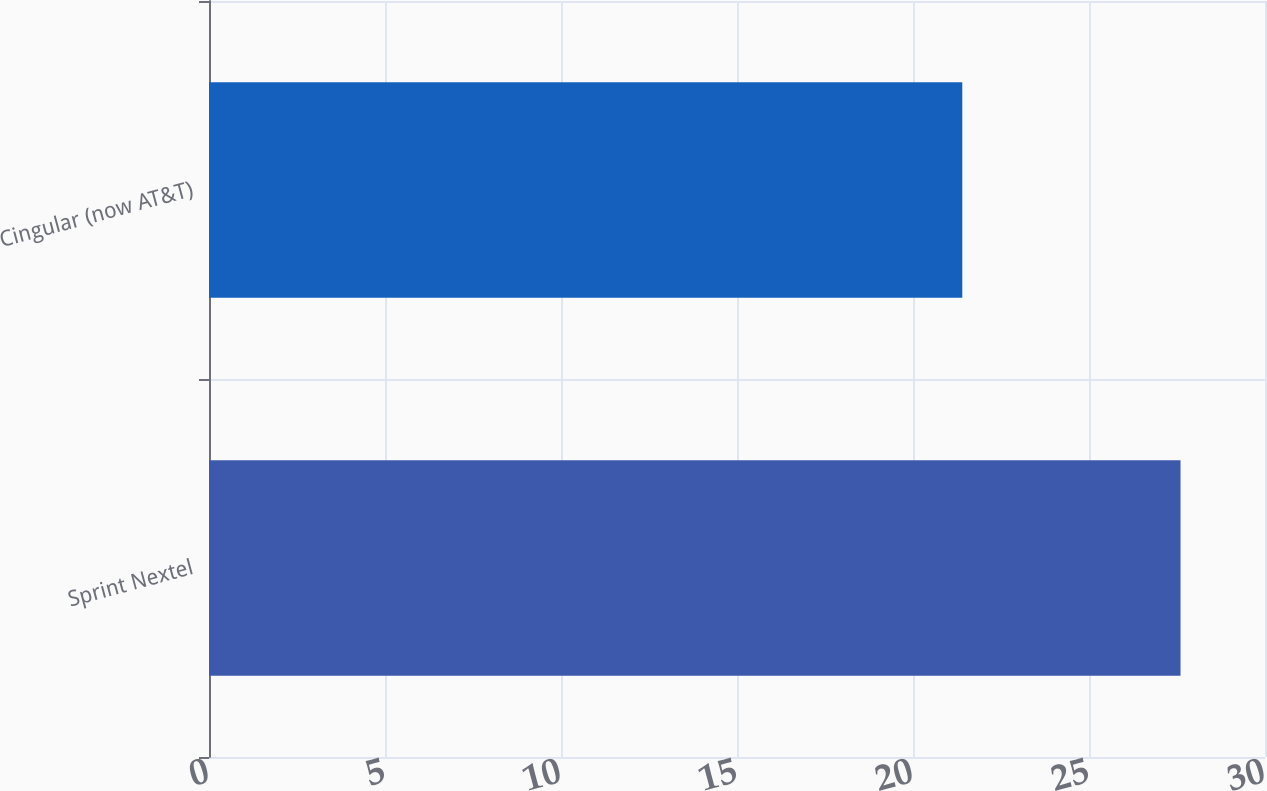<chart> <loc_0><loc_0><loc_500><loc_500><bar_chart><fcel>Sprint Nextel<fcel>Cingular (now AT&T)<nl><fcel>27.6<fcel>21.4<nl></chart> 